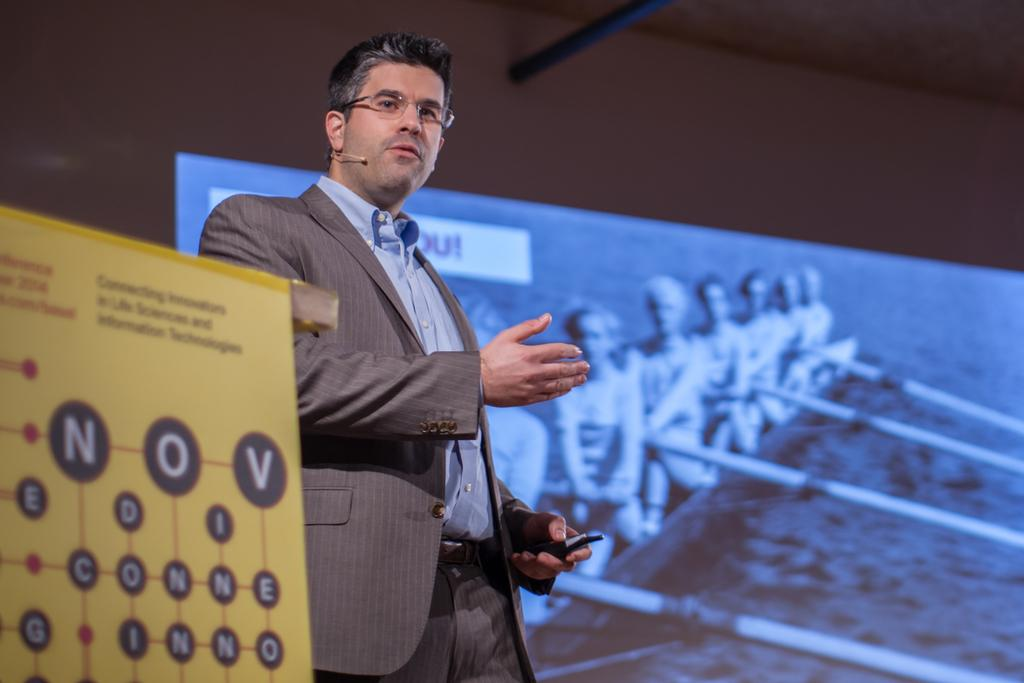What is the person in the image holding? The person is holding something in the image, but the facts do not specify what it is. What is the color of the board in the image? The board in the image is yellow. What can be seen in the background of the image? There is a wall and a screen visible in the background of the image. Are there any visible cobwebs on the wall in the image? There is no mention of cobwebs in the provided facts, so we cannot determine if any are present in the image. 